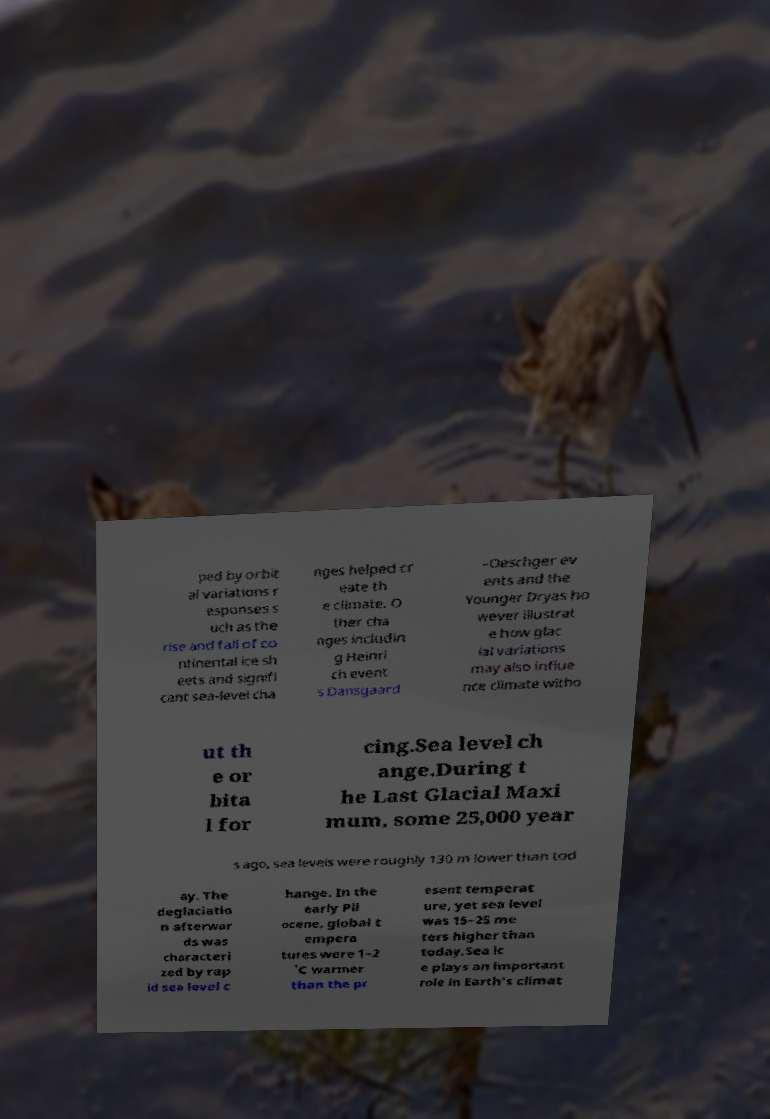There's text embedded in this image that I need extracted. Can you transcribe it verbatim? ped by orbit al variations r esponses s uch as the rise and fall of co ntinental ice sh eets and signifi cant sea-level cha nges helped cr eate th e climate. O ther cha nges includin g Heinri ch event s Dansgaard –Oeschger ev ents and the Younger Dryas ho wever illustrat e how glac ial variations may also influe nce climate witho ut th e or bita l for cing.Sea level ch ange.During t he Last Glacial Maxi mum, some 25,000 year s ago, sea levels were roughly 130 m lower than tod ay. The deglaciatio n afterwar ds was characteri zed by rap id sea level c hange. In the early Pli ocene, global t empera tures were 1–2 ˚C warmer than the pr esent temperat ure, yet sea level was 15–25 me ters higher than today.Sea ic e plays an important role in Earth's climat 